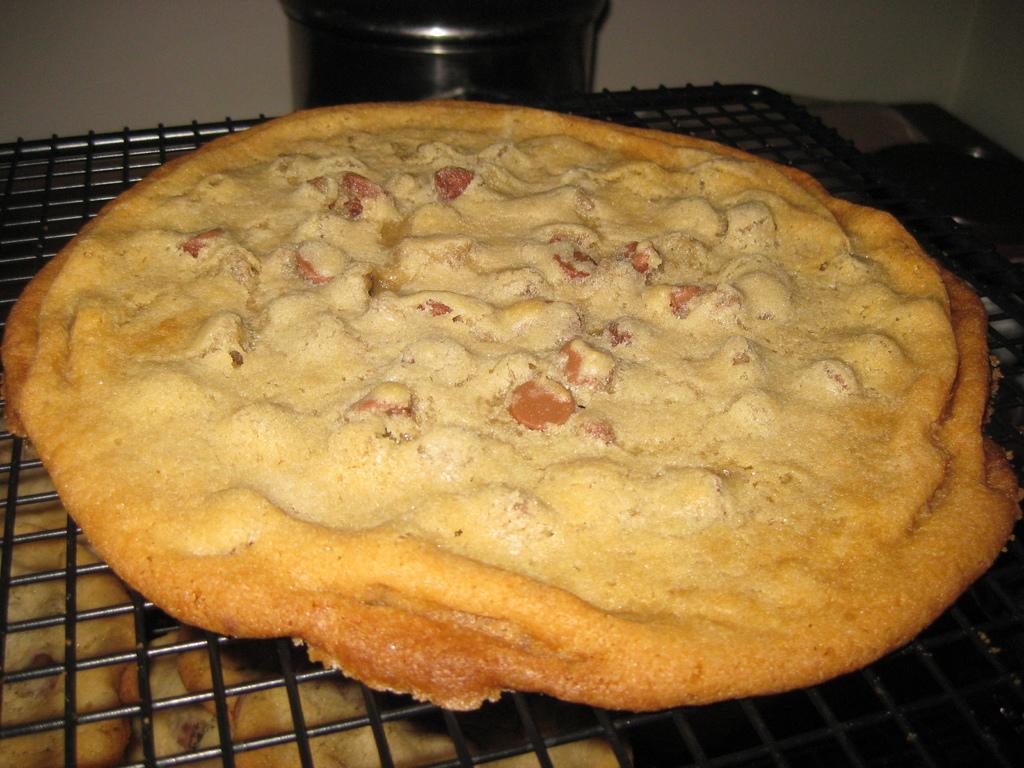Describe this image in one or two sentences. There is a grill. On the grill there is a food item and a vessel. In the back there is a vessel. Below the grill there are some food items. 